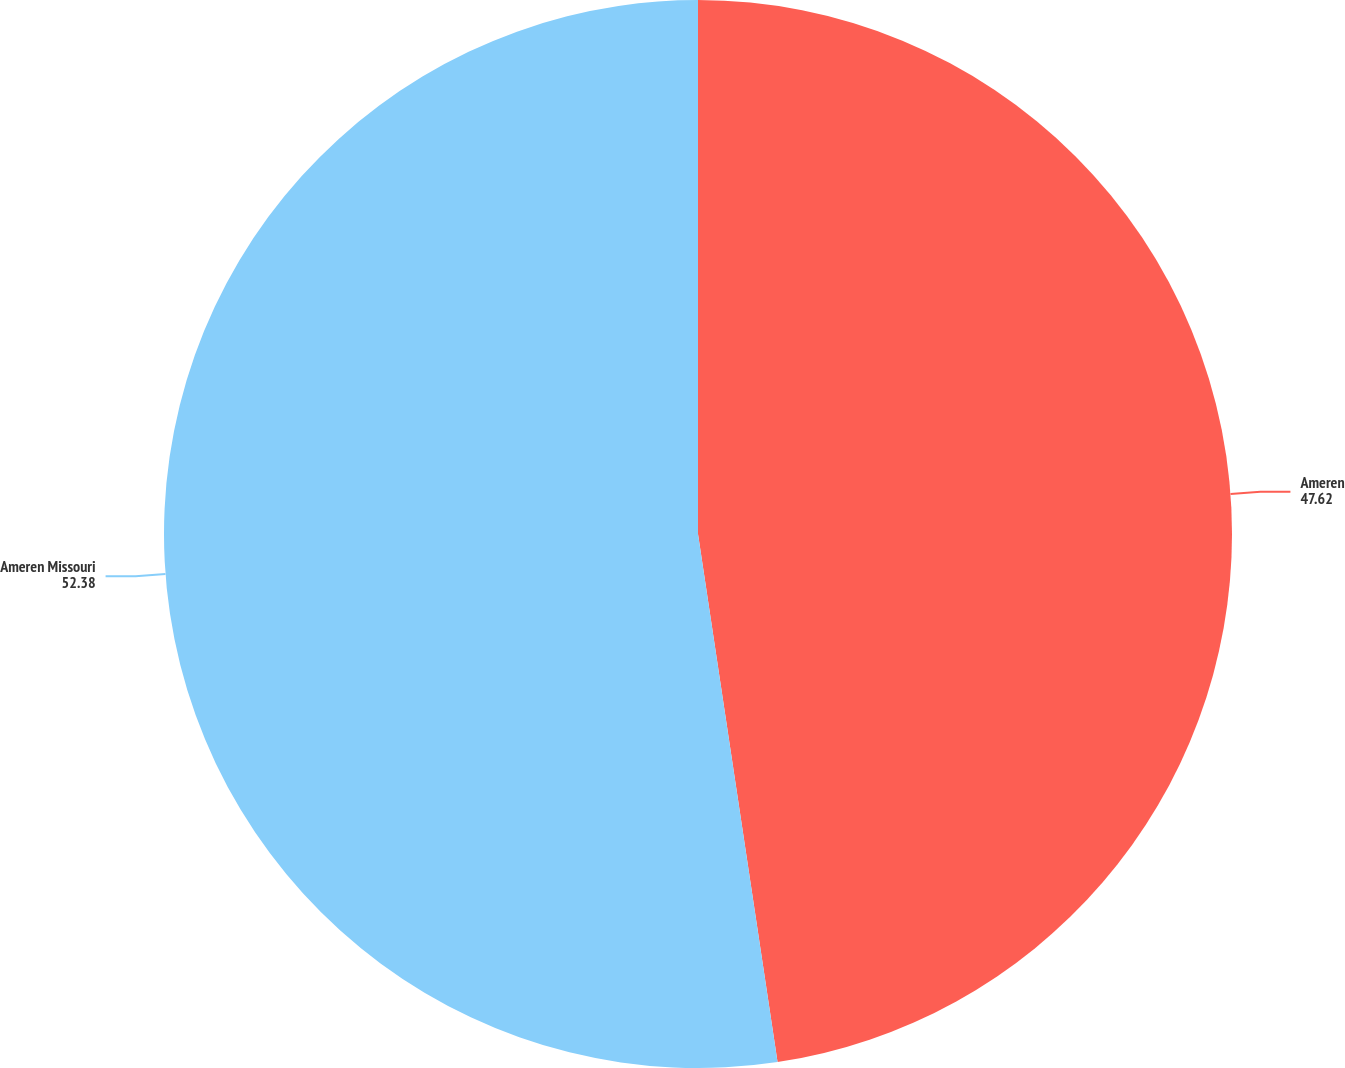Convert chart to OTSL. <chart><loc_0><loc_0><loc_500><loc_500><pie_chart><fcel>Ameren<fcel>Ameren Missouri<nl><fcel>47.62%<fcel>52.38%<nl></chart> 